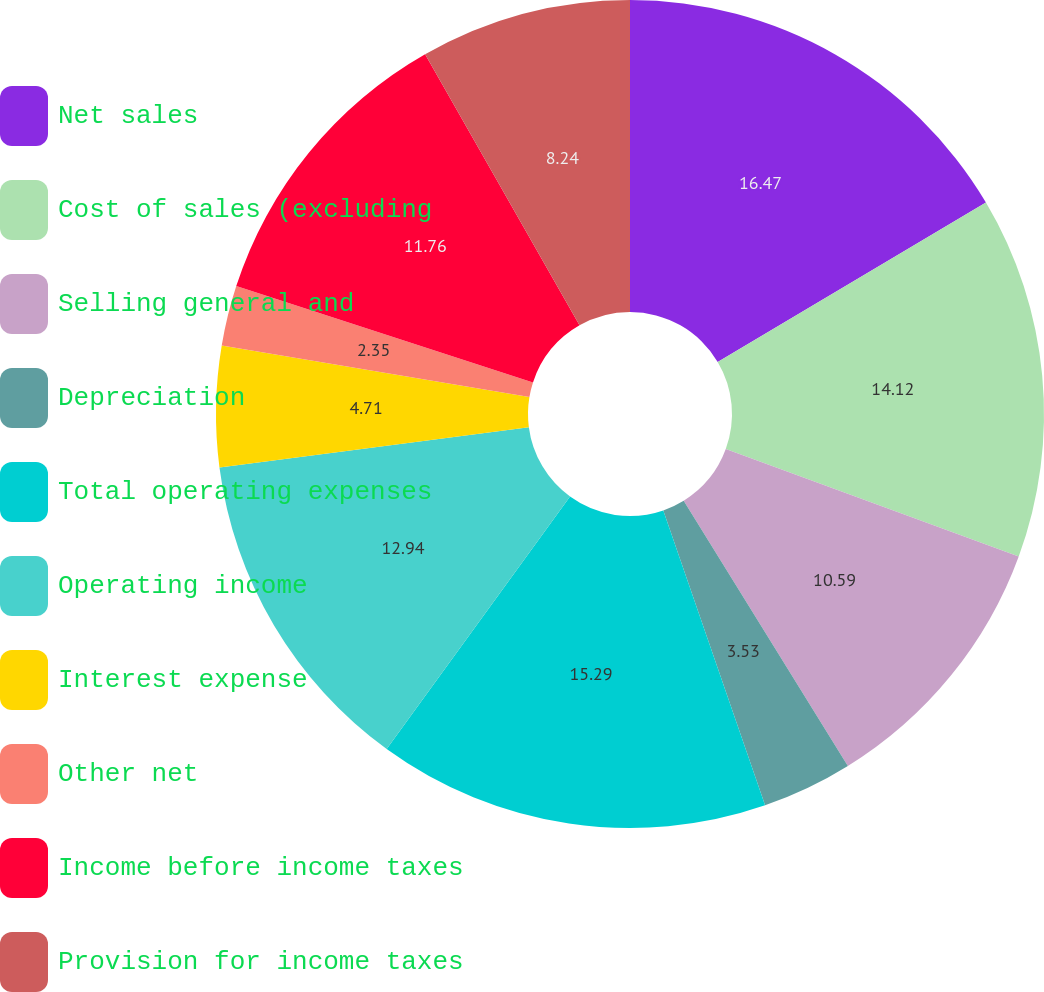Convert chart to OTSL. <chart><loc_0><loc_0><loc_500><loc_500><pie_chart><fcel>Net sales<fcel>Cost of sales (excluding<fcel>Selling general and<fcel>Depreciation<fcel>Total operating expenses<fcel>Operating income<fcel>Interest expense<fcel>Other net<fcel>Income before income taxes<fcel>Provision for income taxes<nl><fcel>16.47%<fcel>14.12%<fcel>10.59%<fcel>3.53%<fcel>15.29%<fcel>12.94%<fcel>4.71%<fcel>2.35%<fcel>11.76%<fcel>8.24%<nl></chart> 